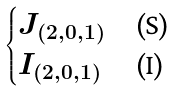<formula> <loc_0><loc_0><loc_500><loc_500>\begin{cases} J _ { ( 2 , 0 , 1 ) } & \text {(S)} \\ I _ { ( 2 , 0 , 1 ) } & \text {(I)} \end{cases}</formula> 